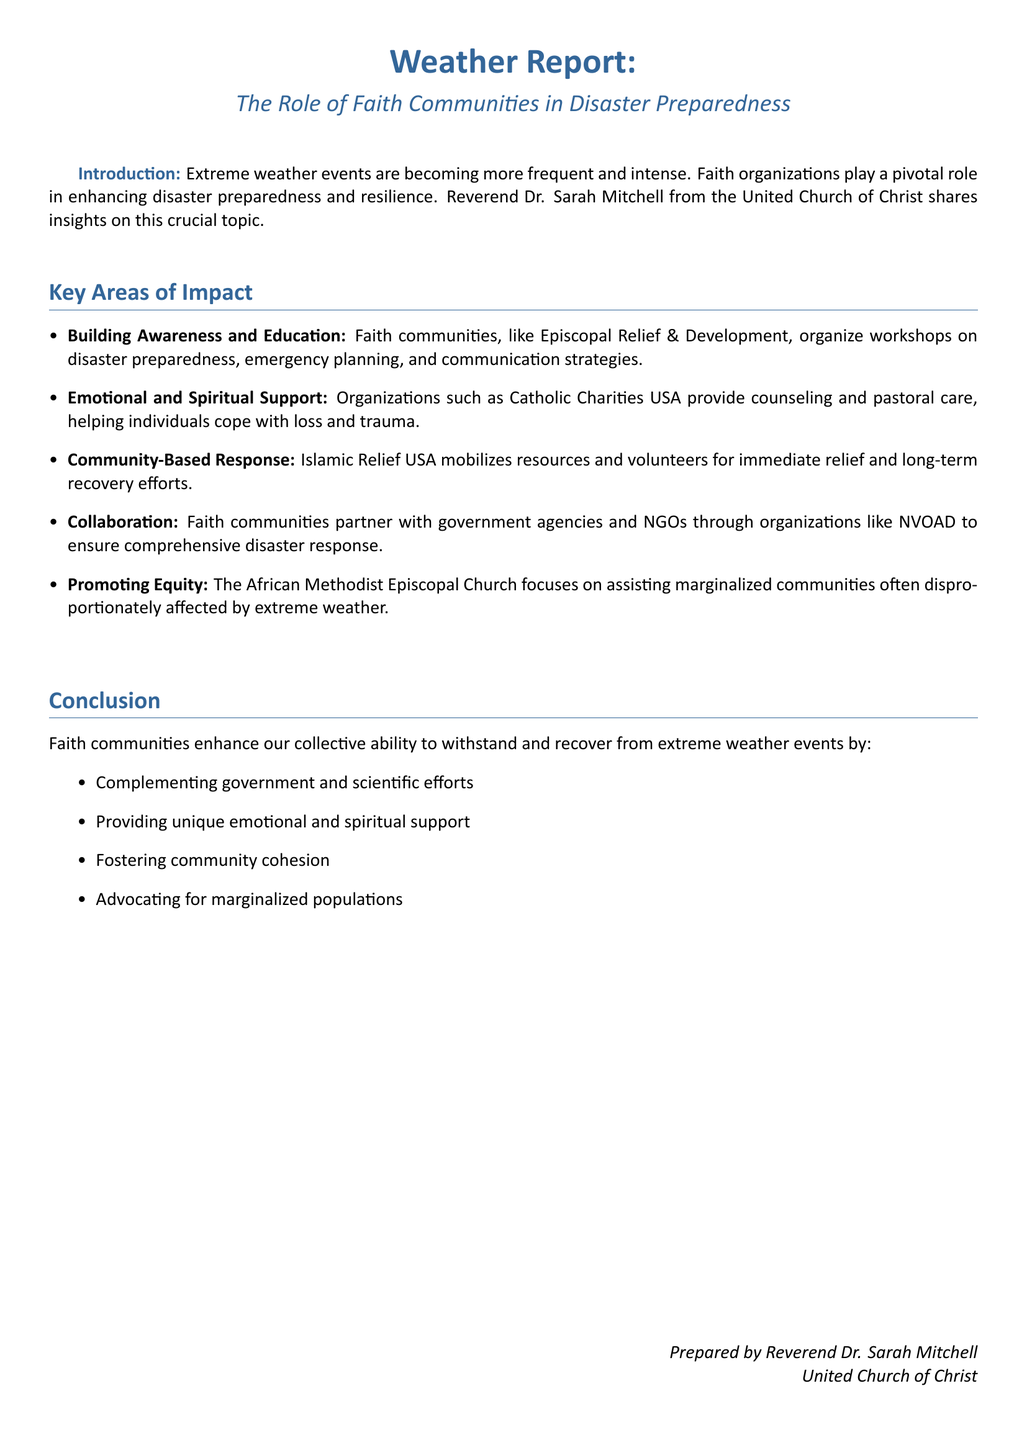What is the title of the document? The title of the document is given in the header and provides the main subject of the report.
Answer: The Role of Faith Communities in Disaster Preparedness Who prepared the report? The document provides the name of the individual who prepared it, as mentioned in the footer.
Answer: Reverend Dr. Sarah Mitchell What organization is mentioned as providing counseling and pastoral care? This information is found in the section regarding emotional and spiritual support, highlighting specific organizations' efforts.
Answer: Catholic Charities USA What is one key area of impact discussed? The document lists several key areas of impact, reflecting the contributions of faith communities.
Answer: Building Awareness and Education Which faith community focuses on equity for marginalized populations? This specific information is provided in the section about promoting equity, identifying how faith communities address social issues.
Answer: African Methodist Episcopal Church What organization mobilizes resources for relief efforts? This is noted in the community-based response area, mentioning specific operations related to disaster relief.
Answer: Islamic Relief USA What type of support do faith communities provide in addition to physical aid? This is outlined in the conclusion that emphasizes various types of support offered by faith organizations.
Answer: Emotional and Spiritual Support How many key areas of impact are identified in the document? The number of key areas is summarized in the list format within the document.
Answer: Five What does NVOAD stand for? This organization is mentioned in the collaborative efforts of faith communities with other sectors for disaster response.
Answer: National Voluntary Organizations Active in Disaster 